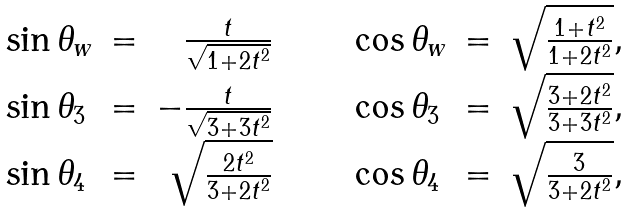<formula> <loc_0><loc_0><loc_500><loc_500>\begin{array} { l l r c c c c l l r c c } \sin { \theta _ { w } } & = & \frac { t } { \sqrt { 1 + 2 t ^ { 2 } } } & & & & & \cos { \theta _ { w } } & = & \sqrt { \frac { 1 + t ^ { 2 } } { 1 + 2 t ^ { 2 } } } , & & \\ \sin { \theta _ { 3 } } & = & - \frac { t } { \sqrt { 3 + 3 t ^ { 2 } } } & & & & & \cos { \theta _ { 3 } } & = & \sqrt { \frac { 3 + 2 t ^ { 2 } } { 3 + 3 t ^ { 2 } } } , & & \\ \sin { \theta _ { 4 } } & = & \sqrt { \frac { 2 t ^ { 2 } } { 3 + 2 t ^ { 2 } } } & & & & & \cos { \theta _ { 4 } } & = & \sqrt { \frac { 3 } { 3 + 2 t ^ { 2 } } } , & & \end{array}</formula> 